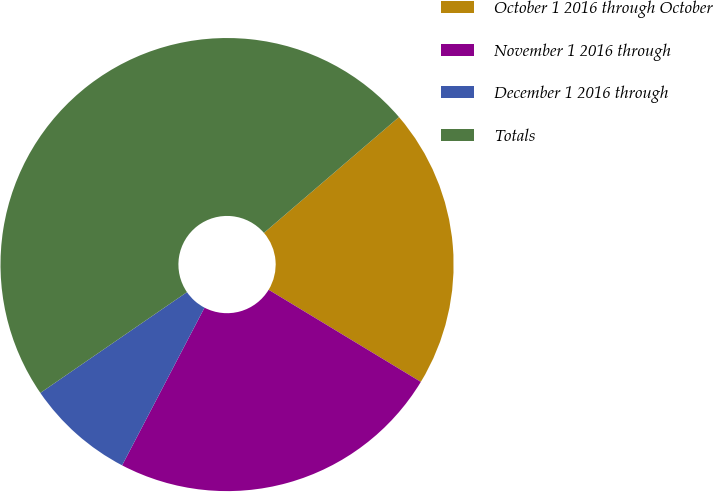Convert chart. <chart><loc_0><loc_0><loc_500><loc_500><pie_chart><fcel>October 1 2016 through October<fcel>November 1 2016 through<fcel>December 1 2016 through<fcel>Totals<nl><fcel>19.95%<fcel>24.0%<fcel>7.75%<fcel>48.3%<nl></chart> 